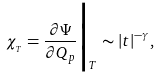Convert formula to latex. <formula><loc_0><loc_0><loc_500><loc_500>\chi _ { _ { T } } = \frac { \partial \Psi } { \partial Q _ { p } } \Big | _ { T } \sim | t | ^ { - \gamma } ,</formula> 